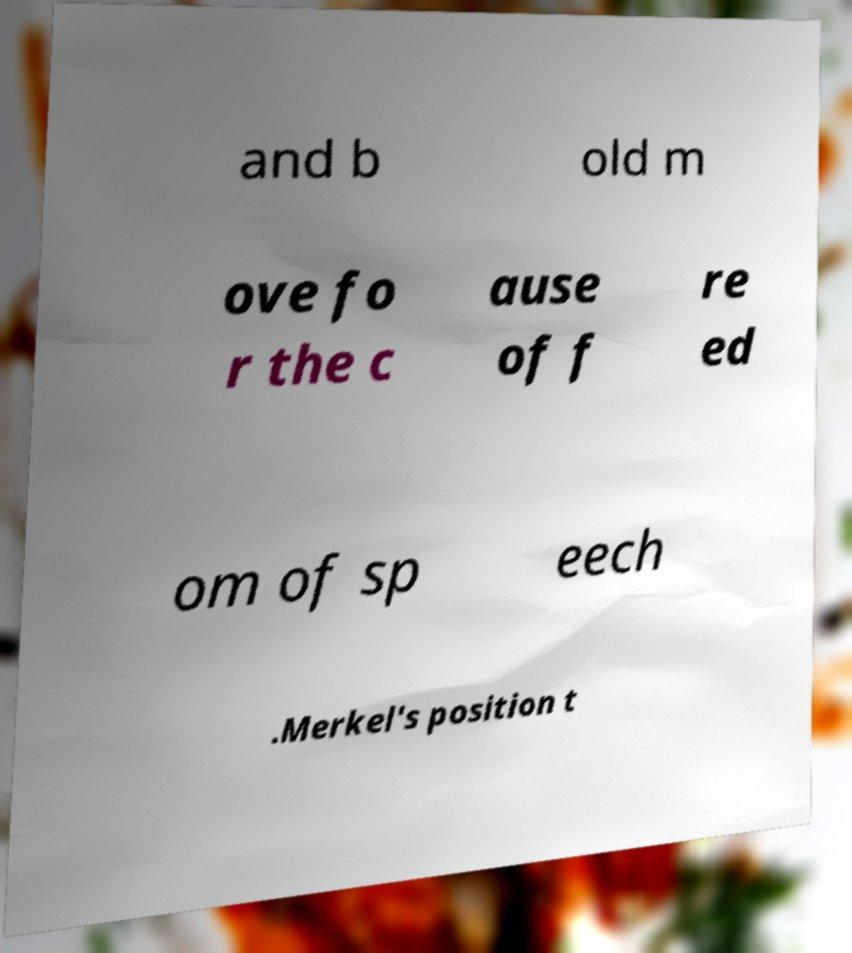Can you read and provide the text displayed in the image?This photo seems to have some interesting text. Can you extract and type it out for me? and b old m ove fo r the c ause of f re ed om of sp eech .Merkel's position t 